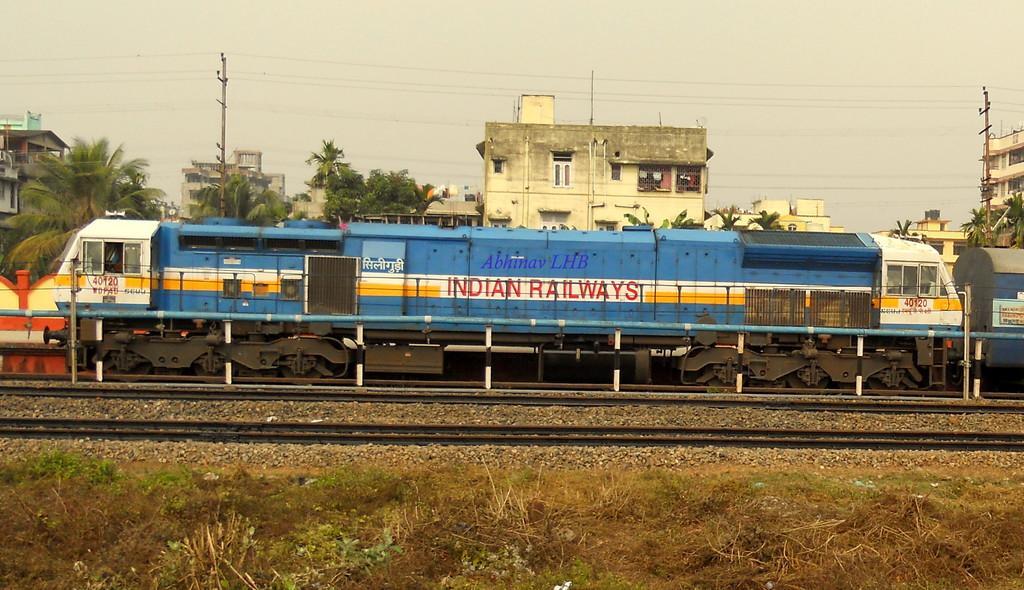Please provide a concise description of this image. In this image, in the middle, we can see a train moving on the railway track. In the background, we can see a wall, trees, buildings, glass window, houses, electric pole, electric wires. At the top, we can see a sky, at the bottom, we can see some stones on the railway track and a grass. 